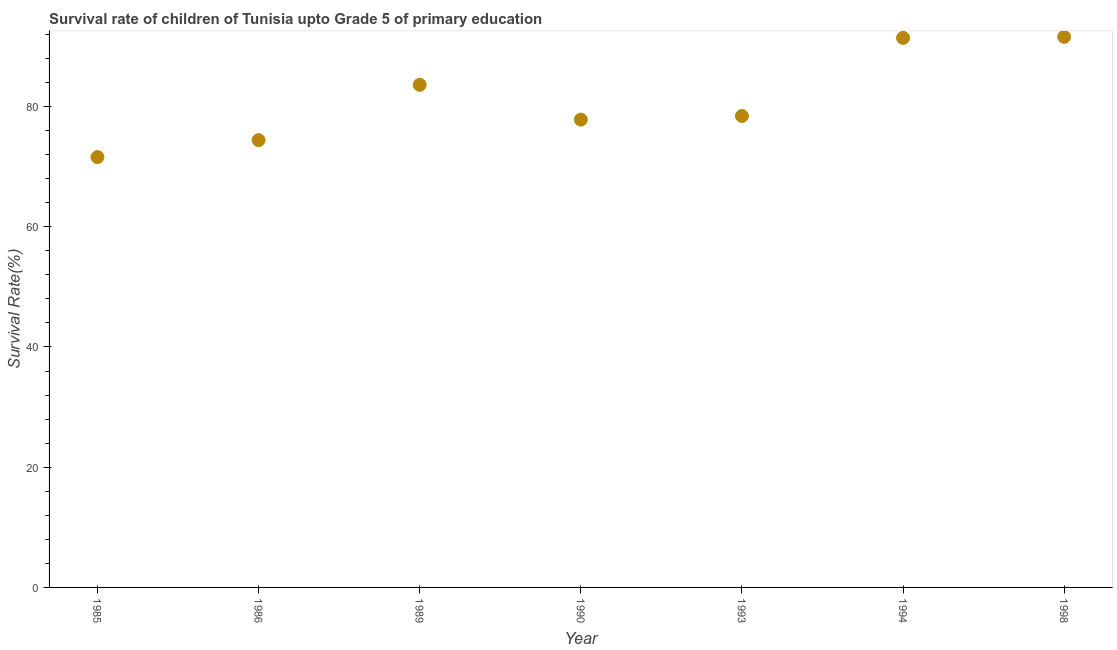What is the survival rate in 1985?
Offer a terse response. 71.59. Across all years, what is the maximum survival rate?
Your answer should be compact. 91.6. Across all years, what is the minimum survival rate?
Your answer should be compact. 71.59. What is the sum of the survival rate?
Your answer should be very brief. 568.89. What is the difference between the survival rate in 1985 and 1990?
Offer a terse response. -6.24. What is the average survival rate per year?
Give a very brief answer. 81.27. What is the median survival rate?
Keep it short and to the point. 78.43. In how many years, is the survival rate greater than 20 %?
Offer a very short reply. 7. Do a majority of the years between 1993 and 1998 (inclusive) have survival rate greater than 16 %?
Your answer should be compact. Yes. What is the ratio of the survival rate in 1986 to that in 1998?
Your answer should be very brief. 0.81. Is the difference between the survival rate in 1985 and 1986 greater than the difference between any two years?
Provide a succinct answer. No. What is the difference between the highest and the second highest survival rate?
Your response must be concise. 0.18. What is the difference between the highest and the lowest survival rate?
Ensure brevity in your answer.  20.01. What is the difference between two consecutive major ticks on the Y-axis?
Offer a terse response. 20. Are the values on the major ticks of Y-axis written in scientific E-notation?
Ensure brevity in your answer.  No. Does the graph contain grids?
Ensure brevity in your answer.  No. What is the title of the graph?
Your response must be concise. Survival rate of children of Tunisia upto Grade 5 of primary education. What is the label or title of the X-axis?
Your response must be concise. Year. What is the label or title of the Y-axis?
Your response must be concise. Survival Rate(%). What is the Survival Rate(%) in 1985?
Provide a short and direct response. 71.59. What is the Survival Rate(%) in 1986?
Offer a very short reply. 74.41. What is the Survival Rate(%) in 1989?
Your answer should be very brief. 83.62. What is the Survival Rate(%) in 1990?
Keep it short and to the point. 77.82. What is the Survival Rate(%) in 1993?
Make the answer very short. 78.43. What is the Survival Rate(%) in 1994?
Keep it short and to the point. 91.42. What is the Survival Rate(%) in 1998?
Offer a terse response. 91.6. What is the difference between the Survival Rate(%) in 1985 and 1986?
Offer a terse response. -2.82. What is the difference between the Survival Rate(%) in 1985 and 1989?
Ensure brevity in your answer.  -12.03. What is the difference between the Survival Rate(%) in 1985 and 1990?
Offer a terse response. -6.24. What is the difference between the Survival Rate(%) in 1985 and 1993?
Your response must be concise. -6.84. What is the difference between the Survival Rate(%) in 1985 and 1994?
Your answer should be very brief. -19.83. What is the difference between the Survival Rate(%) in 1985 and 1998?
Provide a short and direct response. -20.01. What is the difference between the Survival Rate(%) in 1986 and 1989?
Provide a short and direct response. -9.21. What is the difference between the Survival Rate(%) in 1986 and 1990?
Keep it short and to the point. -3.41. What is the difference between the Survival Rate(%) in 1986 and 1993?
Give a very brief answer. -4.02. What is the difference between the Survival Rate(%) in 1986 and 1994?
Your answer should be compact. -17.01. What is the difference between the Survival Rate(%) in 1986 and 1998?
Offer a very short reply. -17.19. What is the difference between the Survival Rate(%) in 1989 and 1990?
Offer a terse response. 5.79. What is the difference between the Survival Rate(%) in 1989 and 1993?
Make the answer very short. 5.19. What is the difference between the Survival Rate(%) in 1989 and 1994?
Keep it short and to the point. -7.8. What is the difference between the Survival Rate(%) in 1989 and 1998?
Offer a terse response. -7.98. What is the difference between the Survival Rate(%) in 1990 and 1993?
Your answer should be very brief. -0.61. What is the difference between the Survival Rate(%) in 1990 and 1994?
Give a very brief answer. -13.6. What is the difference between the Survival Rate(%) in 1990 and 1998?
Offer a very short reply. -13.77. What is the difference between the Survival Rate(%) in 1993 and 1994?
Your answer should be compact. -12.99. What is the difference between the Survival Rate(%) in 1993 and 1998?
Give a very brief answer. -13.17. What is the difference between the Survival Rate(%) in 1994 and 1998?
Offer a terse response. -0.18. What is the ratio of the Survival Rate(%) in 1985 to that in 1989?
Give a very brief answer. 0.86. What is the ratio of the Survival Rate(%) in 1985 to that in 1994?
Your answer should be very brief. 0.78. What is the ratio of the Survival Rate(%) in 1985 to that in 1998?
Your answer should be compact. 0.78. What is the ratio of the Survival Rate(%) in 1986 to that in 1989?
Give a very brief answer. 0.89. What is the ratio of the Survival Rate(%) in 1986 to that in 1990?
Offer a terse response. 0.96. What is the ratio of the Survival Rate(%) in 1986 to that in 1993?
Make the answer very short. 0.95. What is the ratio of the Survival Rate(%) in 1986 to that in 1994?
Your answer should be compact. 0.81. What is the ratio of the Survival Rate(%) in 1986 to that in 1998?
Offer a very short reply. 0.81. What is the ratio of the Survival Rate(%) in 1989 to that in 1990?
Your answer should be compact. 1.07. What is the ratio of the Survival Rate(%) in 1989 to that in 1993?
Offer a very short reply. 1.07. What is the ratio of the Survival Rate(%) in 1989 to that in 1994?
Make the answer very short. 0.92. What is the ratio of the Survival Rate(%) in 1989 to that in 1998?
Your answer should be very brief. 0.91. What is the ratio of the Survival Rate(%) in 1990 to that in 1993?
Your response must be concise. 0.99. What is the ratio of the Survival Rate(%) in 1990 to that in 1994?
Provide a short and direct response. 0.85. What is the ratio of the Survival Rate(%) in 1990 to that in 1998?
Make the answer very short. 0.85. What is the ratio of the Survival Rate(%) in 1993 to that in 1994?
Offer a very short reply. 0.86. What is the ratio of the Survival Rate(%) in 1993 to that in 1998?
Your answer should be very brief. 0.86. What is the ratio of the Survival Rate(%) in 1994 to that in 1998?
Offer a very short reply. 1. 